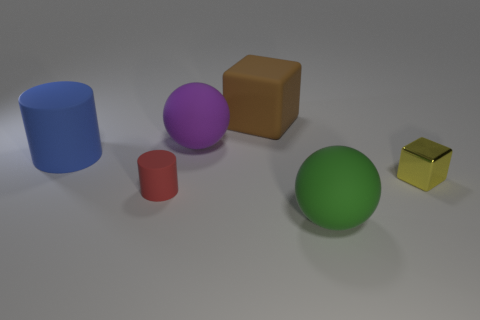What materials do the objects seem to be made of? Based on the image, the objects appear to have a matte surface, suggesting that they could be made of materials like rubber or plastic, which have that kind of texture. Which of these objects stands out the most to you? The purple sphere stands out due to its vibrant color and the fact that it contrasts with the other shapes, as the only perfect sphere among the assortment of objects. 